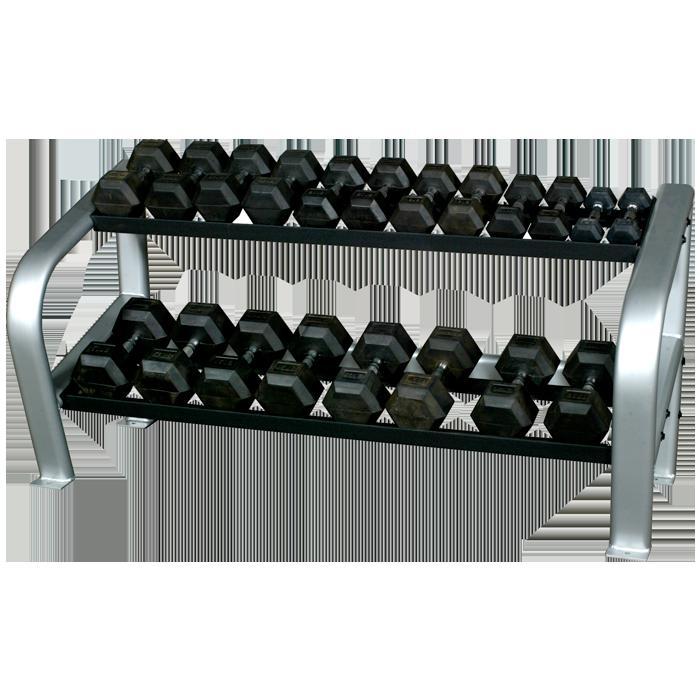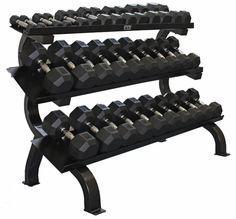The first image is the image on the left, the second image is the image on the right. For the images shown, is this caption "One rack has three tiers to hold dumbbells, and the other rack has only two shelves for weights." true? Answer yes or no. Yes. The first image is the image on the left, the second image is the image on the right. Examine the images to the left and right. Is the description "There are six rows on weights with three rows in each image, and each image's rows of weights are facing opposite directions." accurate? Answer yes or no. No. 